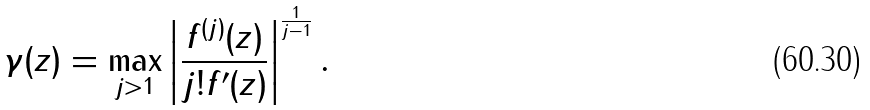Convert formula to latex. <formula><loc_0><loc_0><loc_500><loc_500>\gamma ( z ) = \max _ { j > 1 } \left | \frac { f ^ { ( j ) } ( z ) } { j ! f ^ { \prime } ( z ) } \right | ^ { \frac { 1 } { j - 1 } } .</formula> 